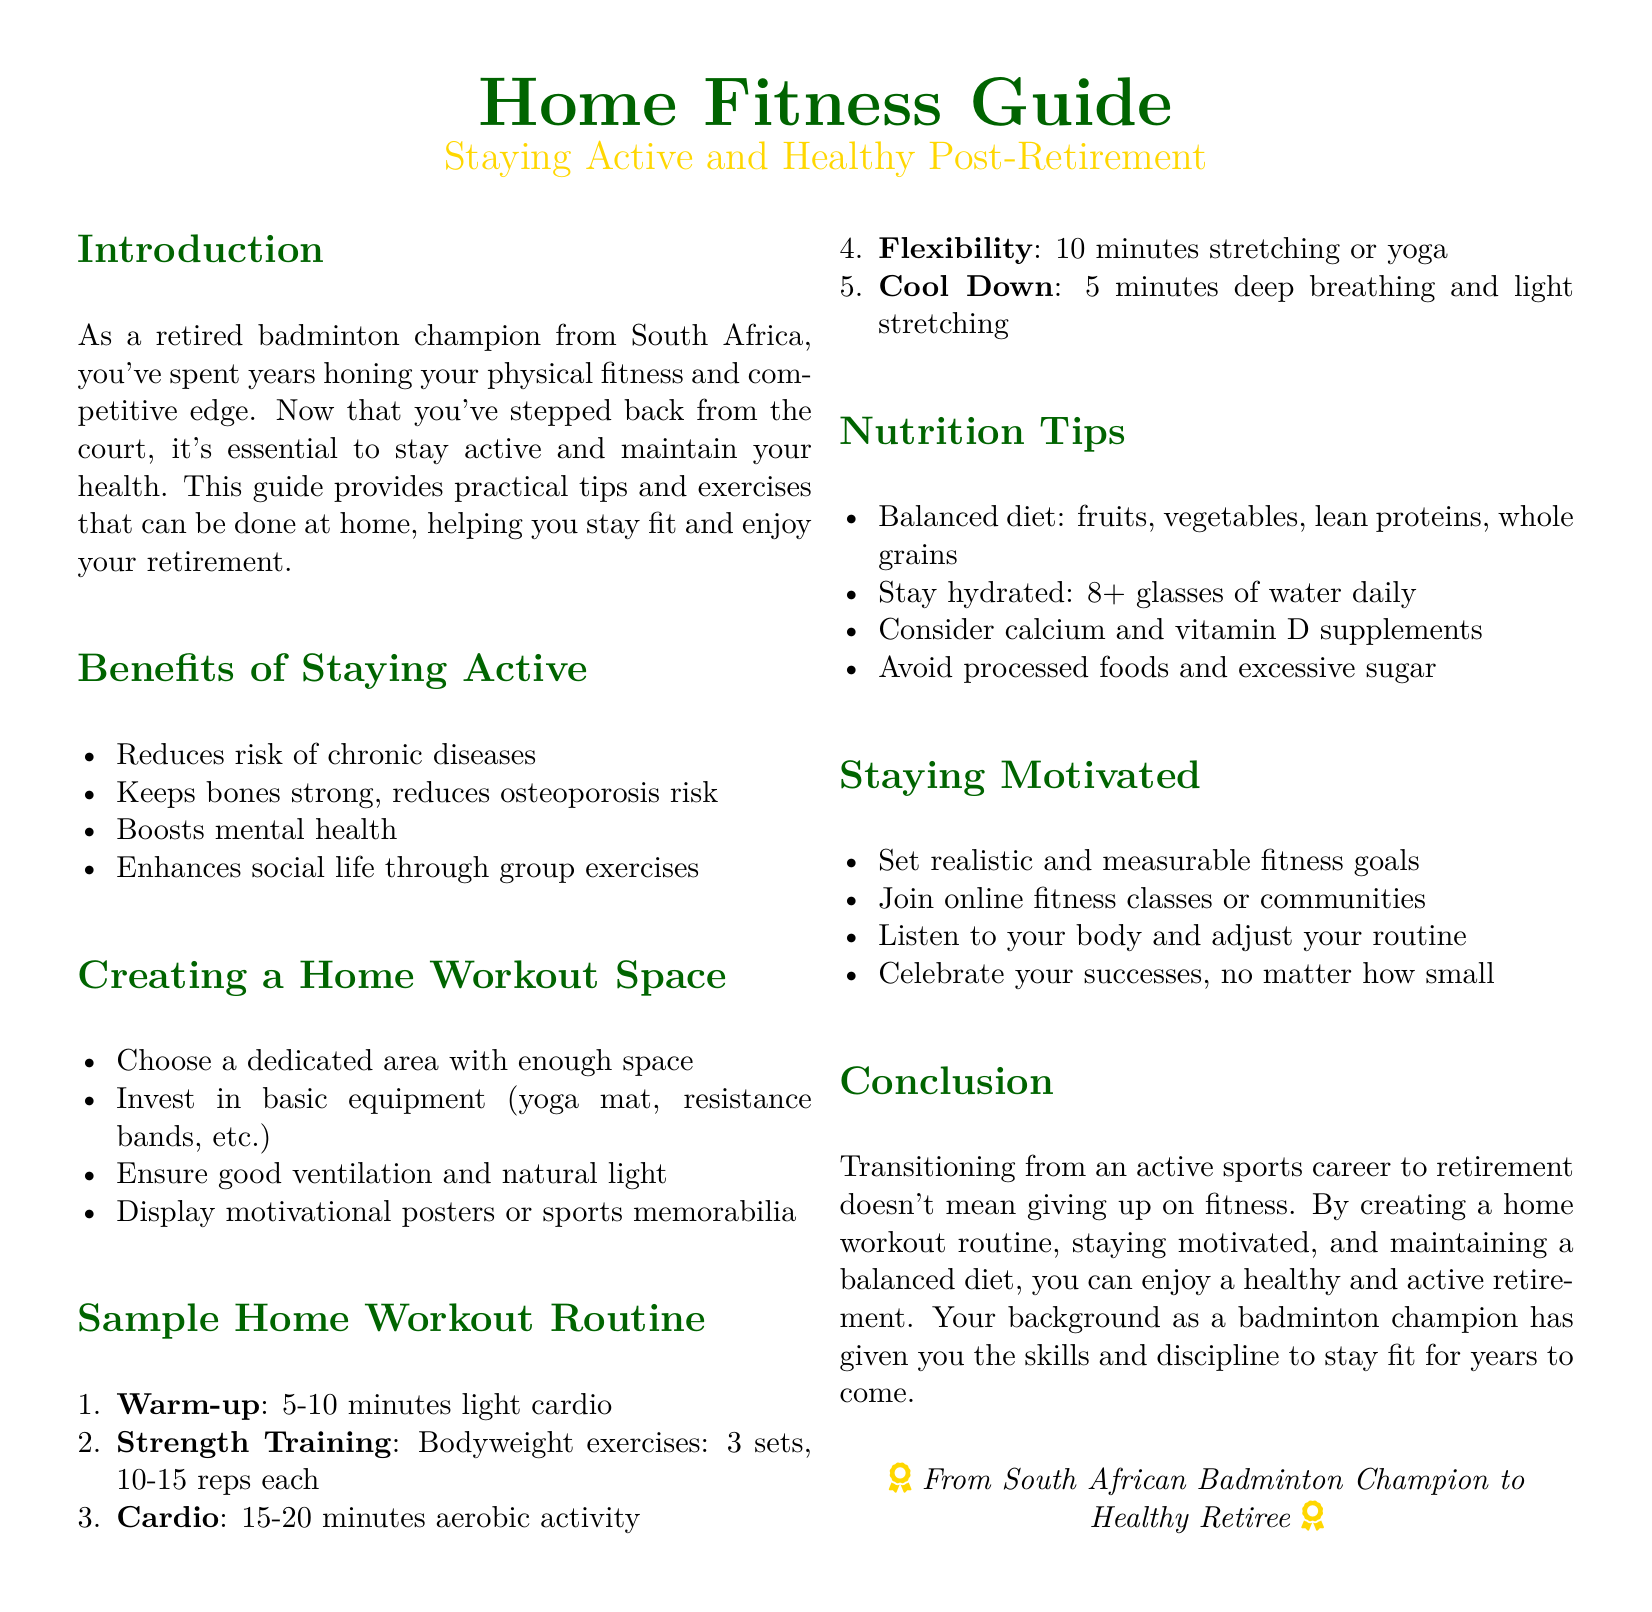What are the benefits of staying active? The document lists several benefits of staying active, including reducing the risk of chronic diseases and boosting mental health.
Answer: Reduces risk of chronic diseases, keeps bones strong, boosts mental health, enhances social life How many minutes should the warm-up last? The warm-up is suggested to last for 5-10 minutes according to the sample home workout routine.
Answer: 5-10 minutes What equipment is recommended for a home workout space? The guide recommends investing in basic equipment such as a yoga mat and resistance bands for a home workout space.
Answer: Yoga mat, resistance bands What is included in the sample strength training? The sample strength training consists of bodyweight exercises performed in sets.
Answer: Bodyweight exercises: 3 sets, 10-15 reps each What is one nutrition tip mentioned in this guide? The guide provides various nutrition tips, one of which is to maintain a balanced diet.
Answer: Balanced diet What can help in staying motivated according to this guide? The guide suggests setting realistic and measurable fitness goals to help stay motivated.
Answer: Set realistic and measurable fitness goals What is the main conclusion of the document? The conclusion emphasizes that transitioning from an active sports career to retirement doesn't mean giving up on fitness.
Answer: Doesn't mean giving up on fitness How many glasses of water should one drink daily? The guide states that one should stay hydrated by drinking more than 8 glasses of water daily.
Answer: 8+ glasses What is the overall theme of this document? The theme revolves around staying active and healthy post-retirement through various tips and exercises.
Answer: Staying active and healthy post-retirement 